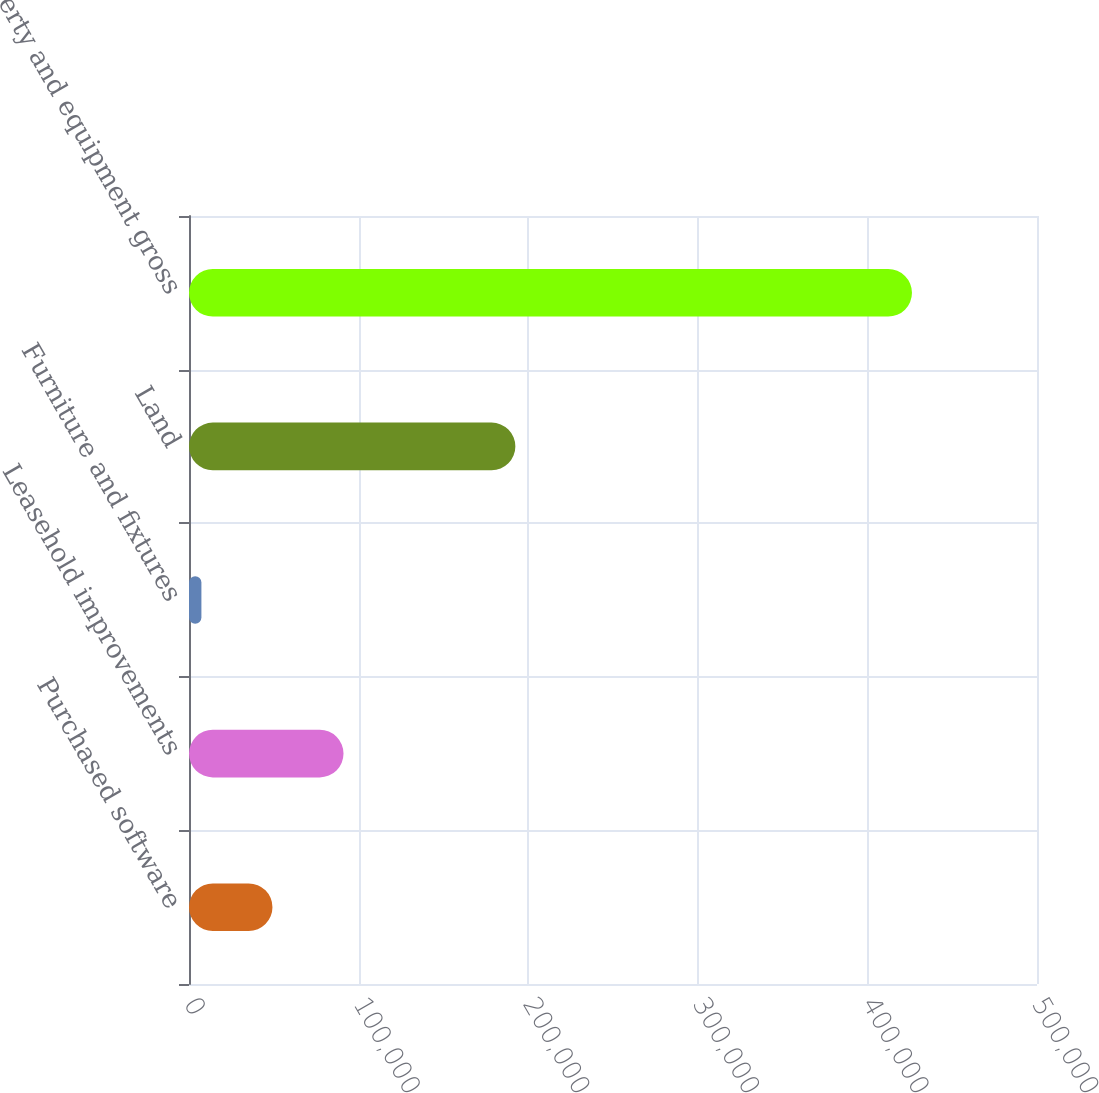Convert chart to OTSL. <chart><loc_0><loc_0><loc_500><loc_500><bar_chart><fcel>Purchased software<fcel>Leasehold improvements<fcel>Furniture and fixtures<fcel>Land<fcel>Property and equipment gross<nl><fcel>49211.6<fcel>91108.2<fcel>7315<fcel>192427<fcel>426281<nl></chart> 